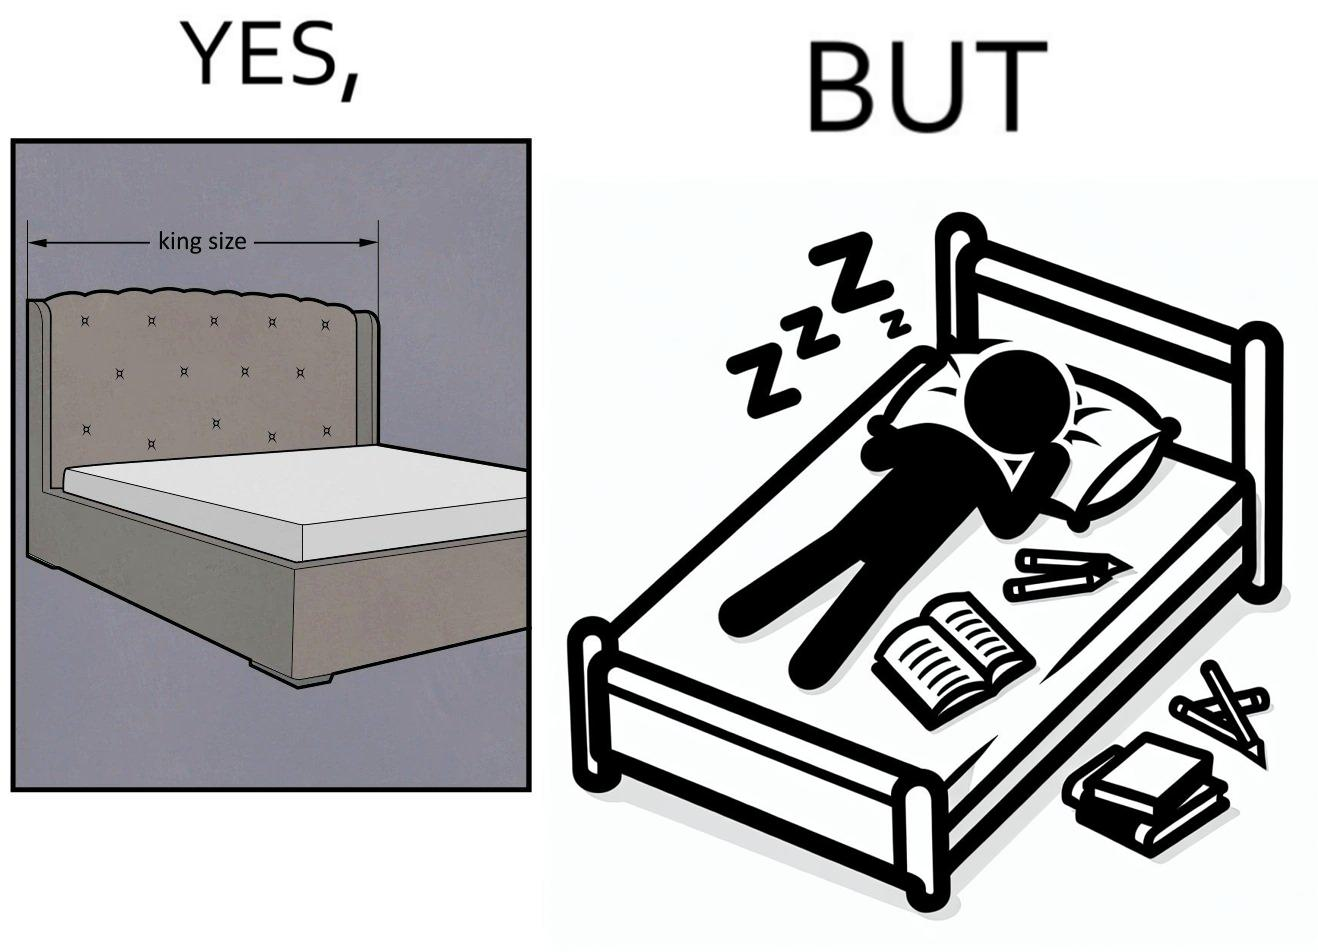Describe the satirical element in this image. Although the person has purchased a king size bed, but only less than half of the space is used by the person for sleeping. 